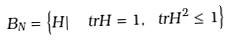Convert formula to latex. <formula><loc_0><loc_0><loc_500><loc_500>B _ { N } = \left \{ H | \ \ t r H = 1 , \ t r H ^ { 2 } \leq 1 \right \}</formula> 